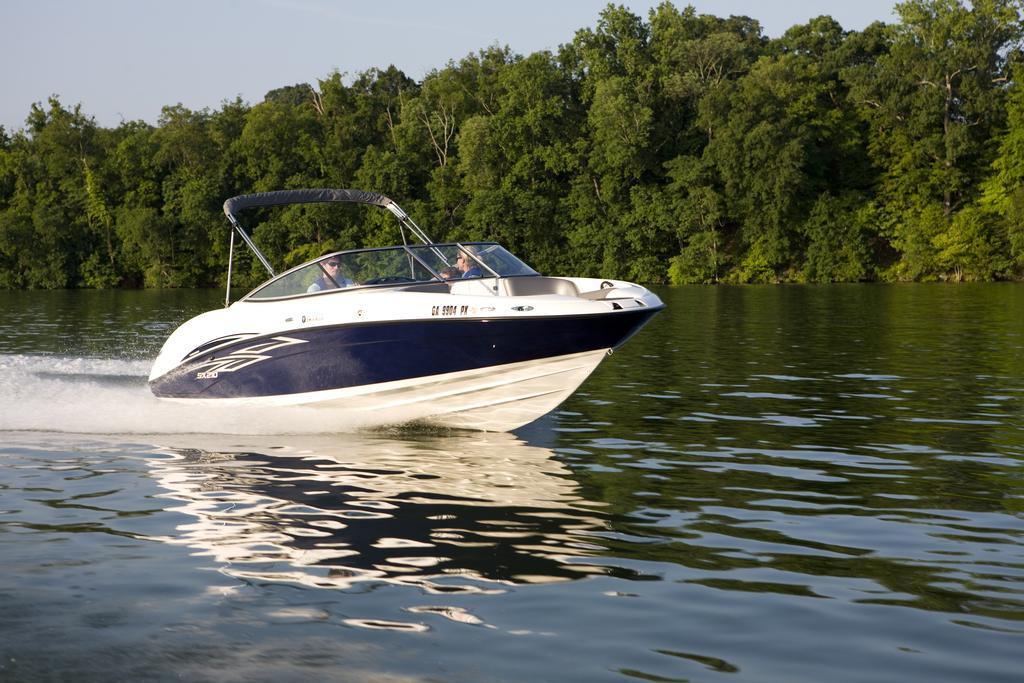Please provide a concise description of this image. In this image, in the middle, we can see a boat which is drowning in the water. In the boat, we can see two people sitting. In the background, we can see some trees, plants. At the top, we can see a sky, at the bottom, we can see water in a lake. 